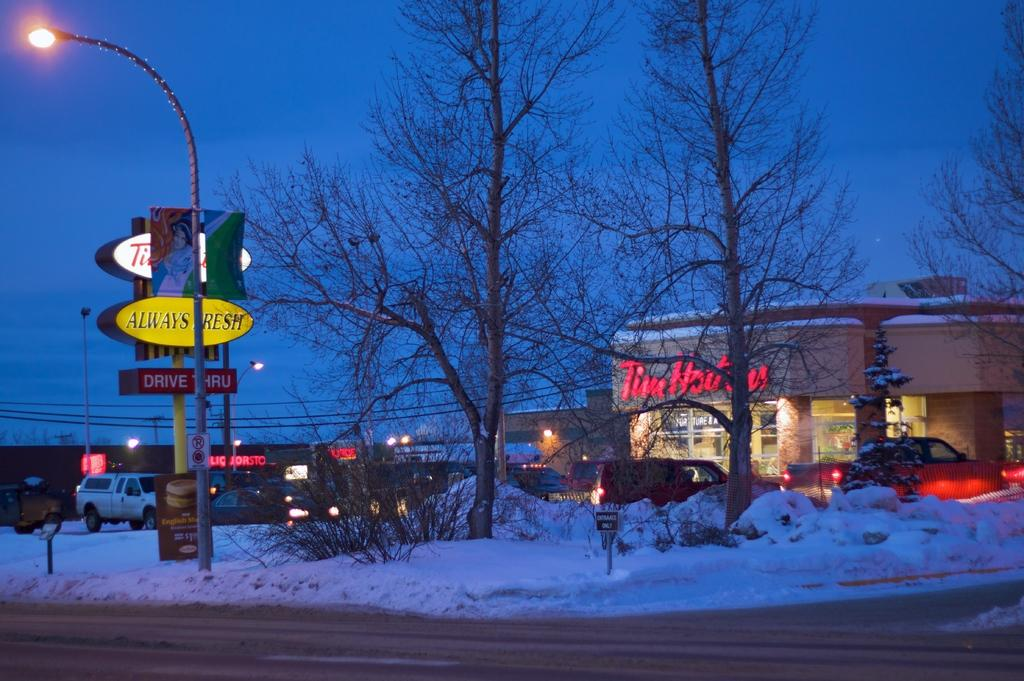Provide a one-sentence caption for the provided image. The yellow sign on this snowy road states Always Fresh. 